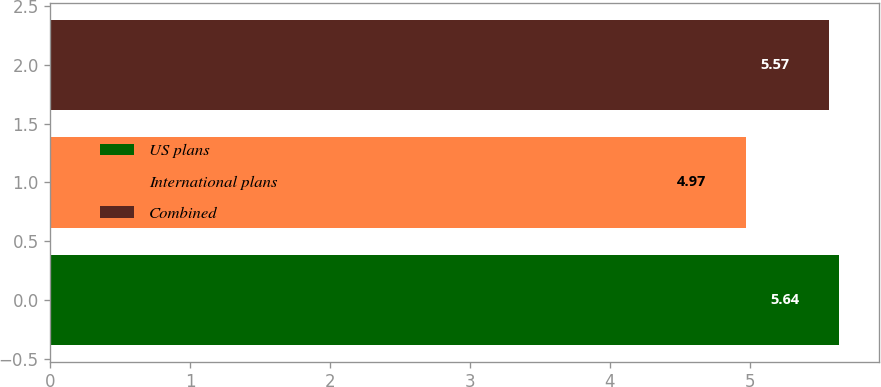Convert chart to OTSL. <chart><loc_0><loc_0><loc_500><loc_500><bar_chart><fcel>US plans<fcel>International plans<fcel>Combined<nl><fcel>5.64<fcel>4.97<fcel>5.57<nl></chart> 